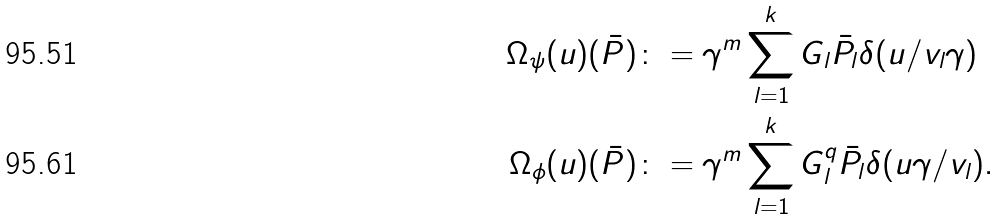Convert formula to latex. <formula><loc_0><loc_0><loc_500><loc_500>\Omega _ { \psi } ( u ) ( \bar { P } ) \colon & = \gamma ^ { m } \sum _ { l = 1 } ^ { k } G _ { l } \bar { P } _ { l } \delta ( u / v _ { l } \gamma ) \\ \Omega _ { \phi } ( u ) ( \bar { P } ) \colon & = \gamma ^ { m } \sum _ { l = 1 } ^ { k } G _ { l } ^ { q } \bar { P } _ { l } \delta ( u \gamma / v _ { l } ) .</formula> 